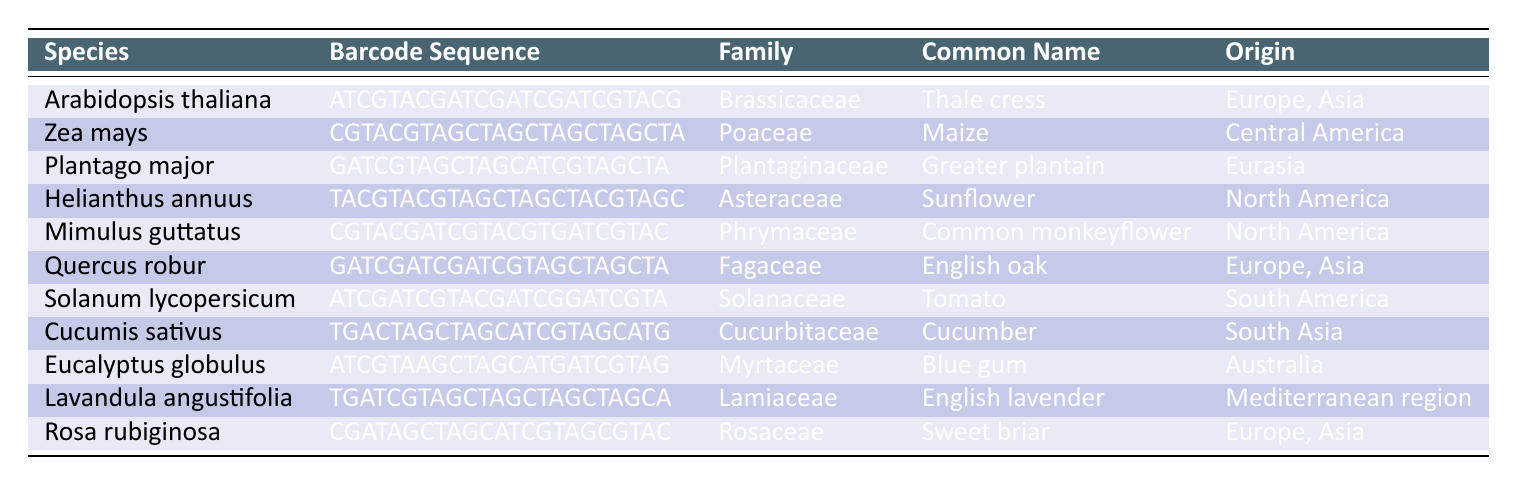What is the common name of the plant species "Mimulus guttatus"? The table lists "Mimulus guttatus" along with its corresponding common name, which is found in the "Common Name" column.
Answer: Common monkeyflower Which plant species has its origin in South America? The "Origin" column shows that "Solanum lycopersicum," also known as Tomato, originates from South America.
Answer: Solanum lycopersicum Are all plants in this table native to Europe? By examining the "Origin" column, it is clear that not all plants are native to Europe; for example, "Zea mays" is from Central America and "Eucalyptus globulus" is from Australia.
Answer: No What is the family name of the plant "Cucumis sativus"? Looking at the row corresponding to "Cucumis sativus," the "Family" column indicates that it belongs to the Cucurbitaceae family.
Answer: Cucurbitaceae How many plant species listed are native to North America? From the table, both "Helianthus annuus" and "Mimulus guttatus" list North America in their origin, making a total of 2 species.
Answer: 2 Which plant has a barcode sequence starting with "ATCGTACG"? The table shows that the barcode sequence for "Arabidopsis thaliana" starts with "ATCGTACG."
Answer: Arabidopsis thaliana Is "Lavandula angustifolia" associated with the family "Rosaceae"? By checking the "Family" column for "Lavandula angustifolia," it is clear that it belongs to the Lamiaceae family, not the Rosaceae family.
Answer: No What are the habitats of "Quercus robur" and "Eucalyptus globulus," and how do they compare? The habitat of "Quercus robur" is woodlands and forests, while "Eucalyptus globulus" grows in forests and open woodlands; both species thrive in forested environments but differ slightly in openness.
Answer: Similar habitats List all species with "European" origin. The "Origin" column reveals that "Arabidopsis thaliana," "Quercus robur," and "Rosa rubiginosa" are all species with European origins.
Answer: Arabidopsis thaliana, Quercus robur, Rosa rubiginosa 